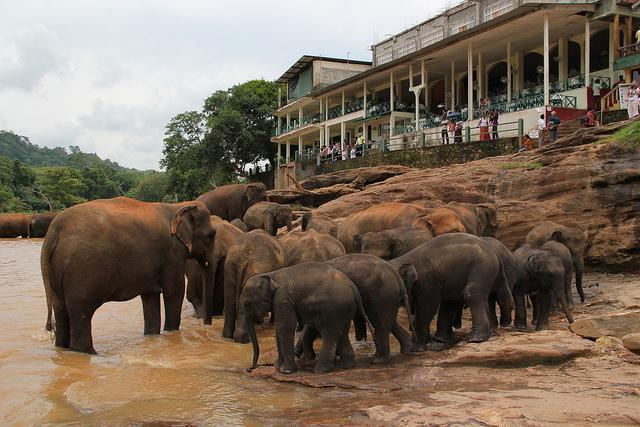How many elephants are visible?
Give a very brief answer. 8. 